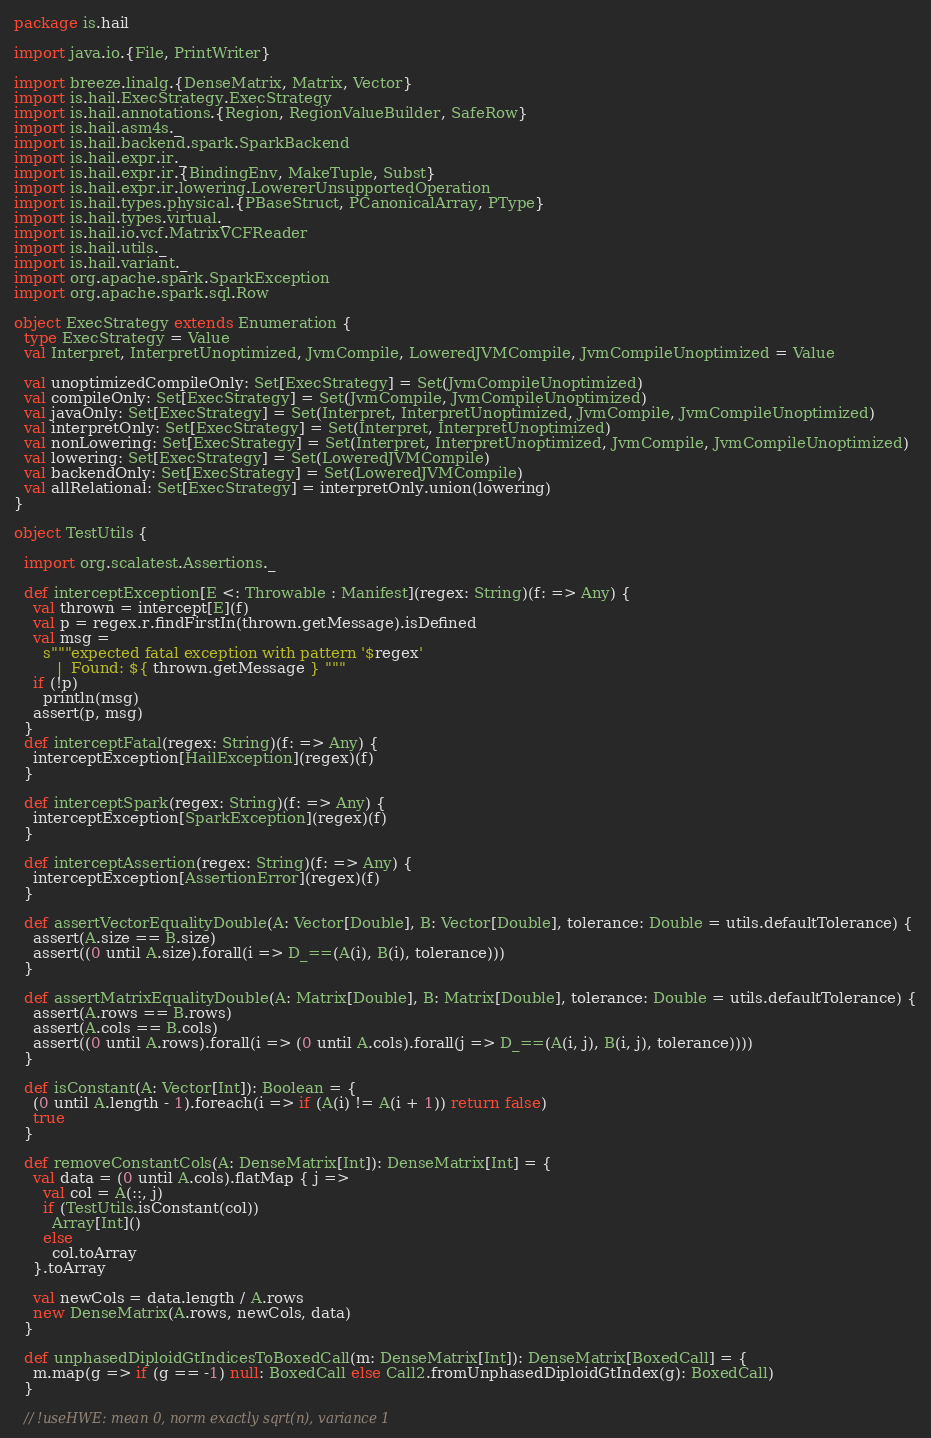Convert code to text. <code><loc_0><loc_0><loc_500><loc_500><_Scala_>package is.hail

import java.io.{File, PrintWriter}

import breeze.linalg.{DenseMatrix, Matrix, Vector}
import is.hail.ExecStrategy.ExecStrategy
import is.hail.annotations.{Region, RegionValueBuilder, SafeRow}
import is.hail.asm4s._
import is.hail.backend.spark.SparkBackend
import is.hail.expr.ir._
import is.hail.expr.ir.{BindingEnv, MakeTuple, Subst}
import is.hail.expr.ir.lowering.LowererUnsupportedOperation
import is.hail.types.physical.{PBaseStruct, PCanonicalArray, PType}
import is.hail.types.virtual._
import is.hail.io.vcf.MatrixVCFReader
import is.hail.utils._
import is.hail.variant._
import org.apache.spark.SparkException
import org.apache.spark.sql.Row

object ExecStrategy extends Enumeration {
  type ExecStrategy = Value
  val Interpret, InterpretUnoptimized, JvmCompile, LoweredJVMCompile, JvmCompileUnoptimized = Value

  val unoptimizedCompileOnly: Set[ExecStrategy] = Set(JvmCompileUnoptimized)
  val compileOnly: Set[ExecStrategy] = Set(JvmCompile, JvmCompileUnoptimized)
  val javaOnly: Set[ExecStrategy] = Set(Interpret, InterpretUnoptimized, JvmCompile, JvmCompileUnoptimized)
  val interpretOnly: Set[ExecStrategy] = Set(Interpret, InterpretUnoptimized)
  val nonLowering: Set[ExecStrategy] = Set(Interpret, InterpretUnoptimized, JvmCompile, JvmCompileUnoptimized)
  val lowering: Set[ExecStrategy] = Set(LoweredJVMCompile)
  val backendOnly: Set[ExecStrategy] = Set(LoweredJVMCompile)
  val allRelational: Set[ExecStrategy] = interpretOnly.union(lowering)
}

object TestUtils {

  import org.scalatest.Assertions._

  def interceptException[E <: Throwable : Manifest](regex: String)(f: => Any) {
    val thrown = intercept[E](f)
    val p = regex.r.findFirstIn(thrown.getMessage).isDefined
    val msg =
      s"""expected fatal exception with pattern '$regex'
         |  Found: ${ thrown.getMessage } """
    if (!p)
      println(msg)
    assert(p, msg)
  }
  def interceptFatal(regex: String)(f: => Any) {
    interceptException[HailException](regex)(f)
  }

  def interceptSpark(regex: String)(f: => Any) {
    interceptException[SparkException](regex)(f)
  }

  def interceptAssertion(regex: String)(f: => Any) {
    interceptException[AssertionError](regex)(f)
  }

  def assertVectorEqualityDouble(A: Vector[Double], B: Vector[Double], tolerance: Double = utils.defaultTolerance) {
    assert(A.size == B.size)
    assert((0 until A.size).forall(i => D_==(A(i), B(i), tolerance)))
  }

  def assertMatrixEqualityDouble(A: Matrix[Double], B: Matrix[Double], tolerance: Double = utils.defaultTolerance) {
    assert(A.rows == B.rows)
    assert(A.cols == B.cols)
    assert((0 until A.rows).forall(i => (0 until A.cols).forall(j => D_==(A(i, j), B(i, j), tolerance))))
  }

  def isConstant(A: Vector[Int]): Boolean = {
    (0 until A.length - 1).foreach(i => if (A(i) != A(i + 1)) return false)
    true
  }

  def removeConstantCols(A: DenseMatrix[Int]): DenseMatrix[Int] = {
    val data = (0 until A.cols).flatMap { j =>
      val col = A(::, j)
      if (TestUtils.isConstant(col))
        Array[Int]()
      else
        col.toArray
    }.toArray

    val newCols = data.length / A.rows
    new DenseMatrix(A.rows, newCols, data)
  }

  def unphasedDiploidGtIndicesToBoxedCall(m: DenseMatrix[Int]): DenseMatrix[BoxedCall] = {
    m.map(g => if (g == -1) null: BoxedCall else Call2.fromUnphasedDiploidGtIndex(g): BoxedCall)
  }

  // !useHWE: mean 0, norm exactly sqrt(n), variance 1</code> 